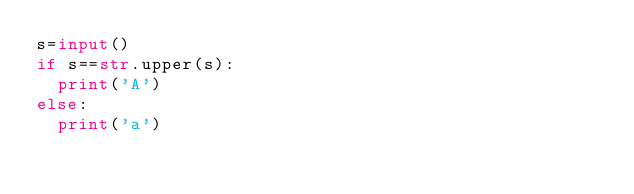<code> <loc_0><loc_0><loc_500><loc_500><_Python_>s=input()
if s==str.upper(s):
  print('A')
else:
  print('a')</code> 